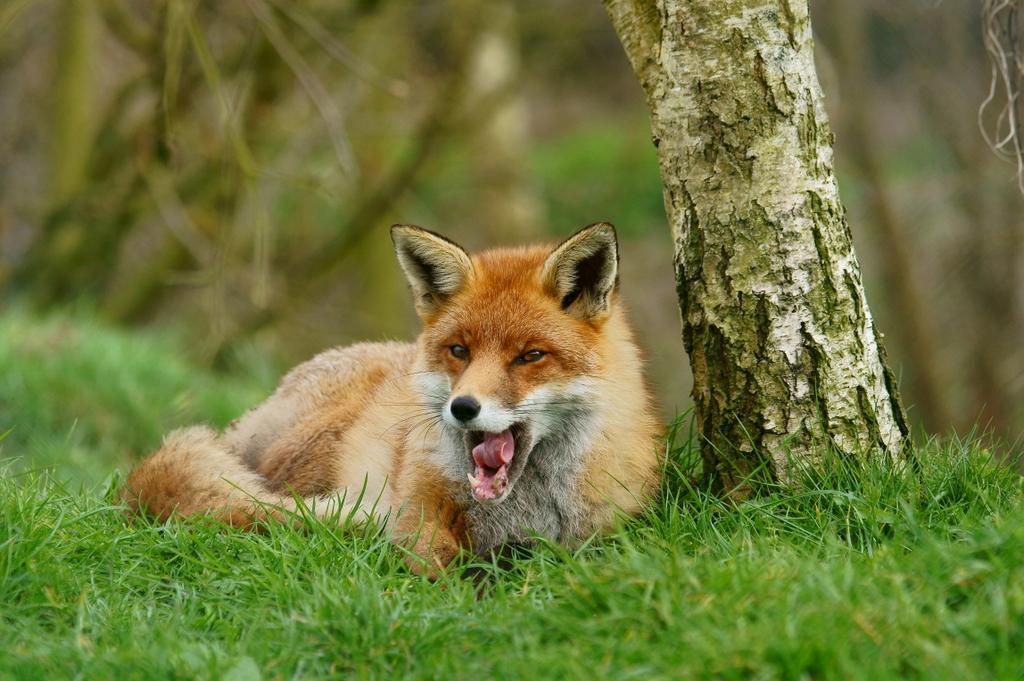Describe this image in one or two sentences. In this image we can see an animal lying on the grass field. In the background, we can see a group of trees. 